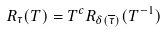<formula> <loc_0><loc_0><loc_500><loc_500>R _ { \tau } ( T ) = T ^ { c } R _ { \delta ( \overline { \tau } ) } ( T ^ { - 1 } )</formula> 